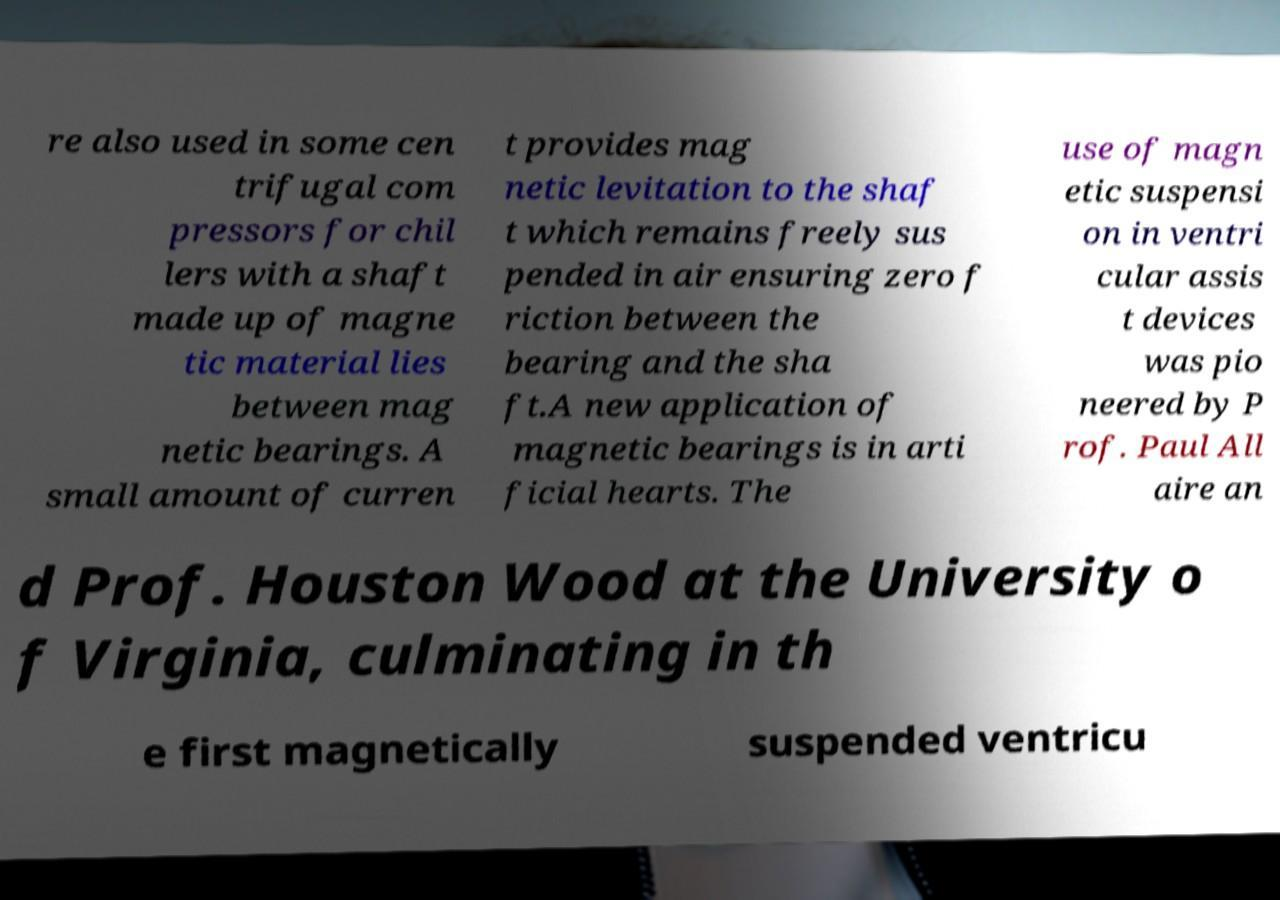There's text embedded in this image that I need extracted. Can you transcribe it verbatim? re also used in some cen trifugal com pressors for chil lers with a shaft made up of magne tic material lies between mag netic bearings. A small amount of curren t provides mag netic levitation to the shaf t which remains freely sus pended in air ensuring zero f riction between the bearing and the sha ft.A new application of magnetic bearings is in arti ficial hearts. The use of magn etic suspensi on in ventri cular assis t devices was pio neered by P rof. Paul All aire an d Prof. Houston Wood at the University o f Virginia, culminating in th e first magnetically suspended ventricu 